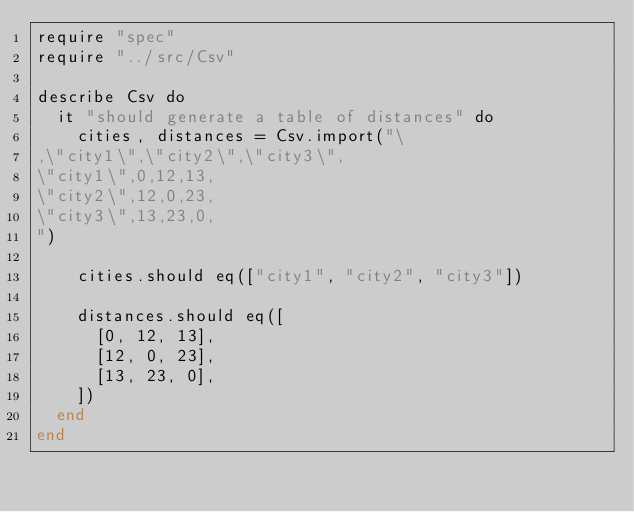Convert code to text. <code><loc_0><loc_0><loc_500><loc_500><_Crystal_>require "spec"
require "../src/Csv"

describe Csv do
  it "should generate a table of distances" do
    cities, distances = Csv.import("\
,\"city1\",\"city2\",\"city3\",
\"city1\",0,12,13,
\"city2\",12,0,23,
\"city3\",13,23,0,
")

    cities.should eq(["city1", "city2", "city3"])

    distances.should eq([
      [0, 12, 13],
      [12, 0, 23],
      [13, 23, 0],
    ])
  end
end
</code> 